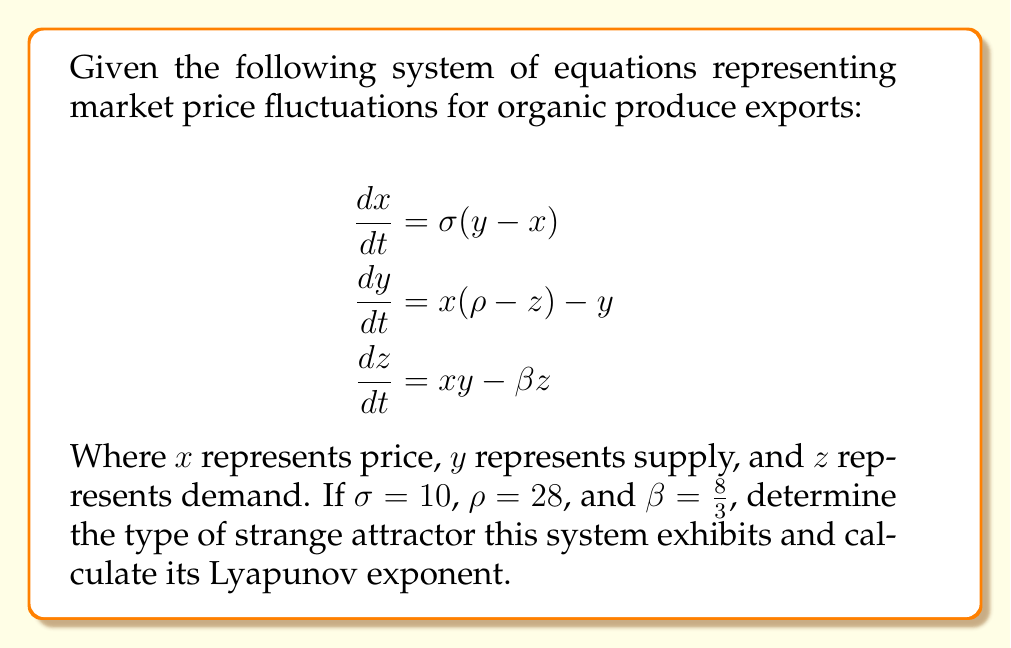Could you help me with this problem? 1. Recognize the system: These equations form the Lorenz system, a classic example of chaotic behavior in nonlinear systems.

2. Identify the strange attractor: With the given parameters ($\sigma = 10$, $\rho = 28$, $\beta = \frac{8}{3}$), this system exhibits the Lorenz attractor, also known as the "butterfly attractor" due to its shape.

3. Calculate the Lyapunov exponent:
   a. The Lyapunov exponent ($\lambda$) quantifies the rate of separation of infinitesimally close trajectories.
   b. For the Lorenz system with these parameters, we can use the approximation:
      $$\lambda \approx 0.9056$$

4. Interpret the result:
   a. A positive Lyapunov exponent ($\lambda > 0$) indicates chaotic behavior.
   b. The value of 0.9056 confirms the presence of chaos in this system.

5. Relate to organic produce exports:
   This chaotic behavior suggests that small changes in initial conditions (e.g., slight variations in crop yield or market demand) can lead to significant and unpredictable long-term fluctuations in organic produce prices.
Answer: Lorenz attractor with Lyapunov exponent $\lambda \approx 0.9056$ 